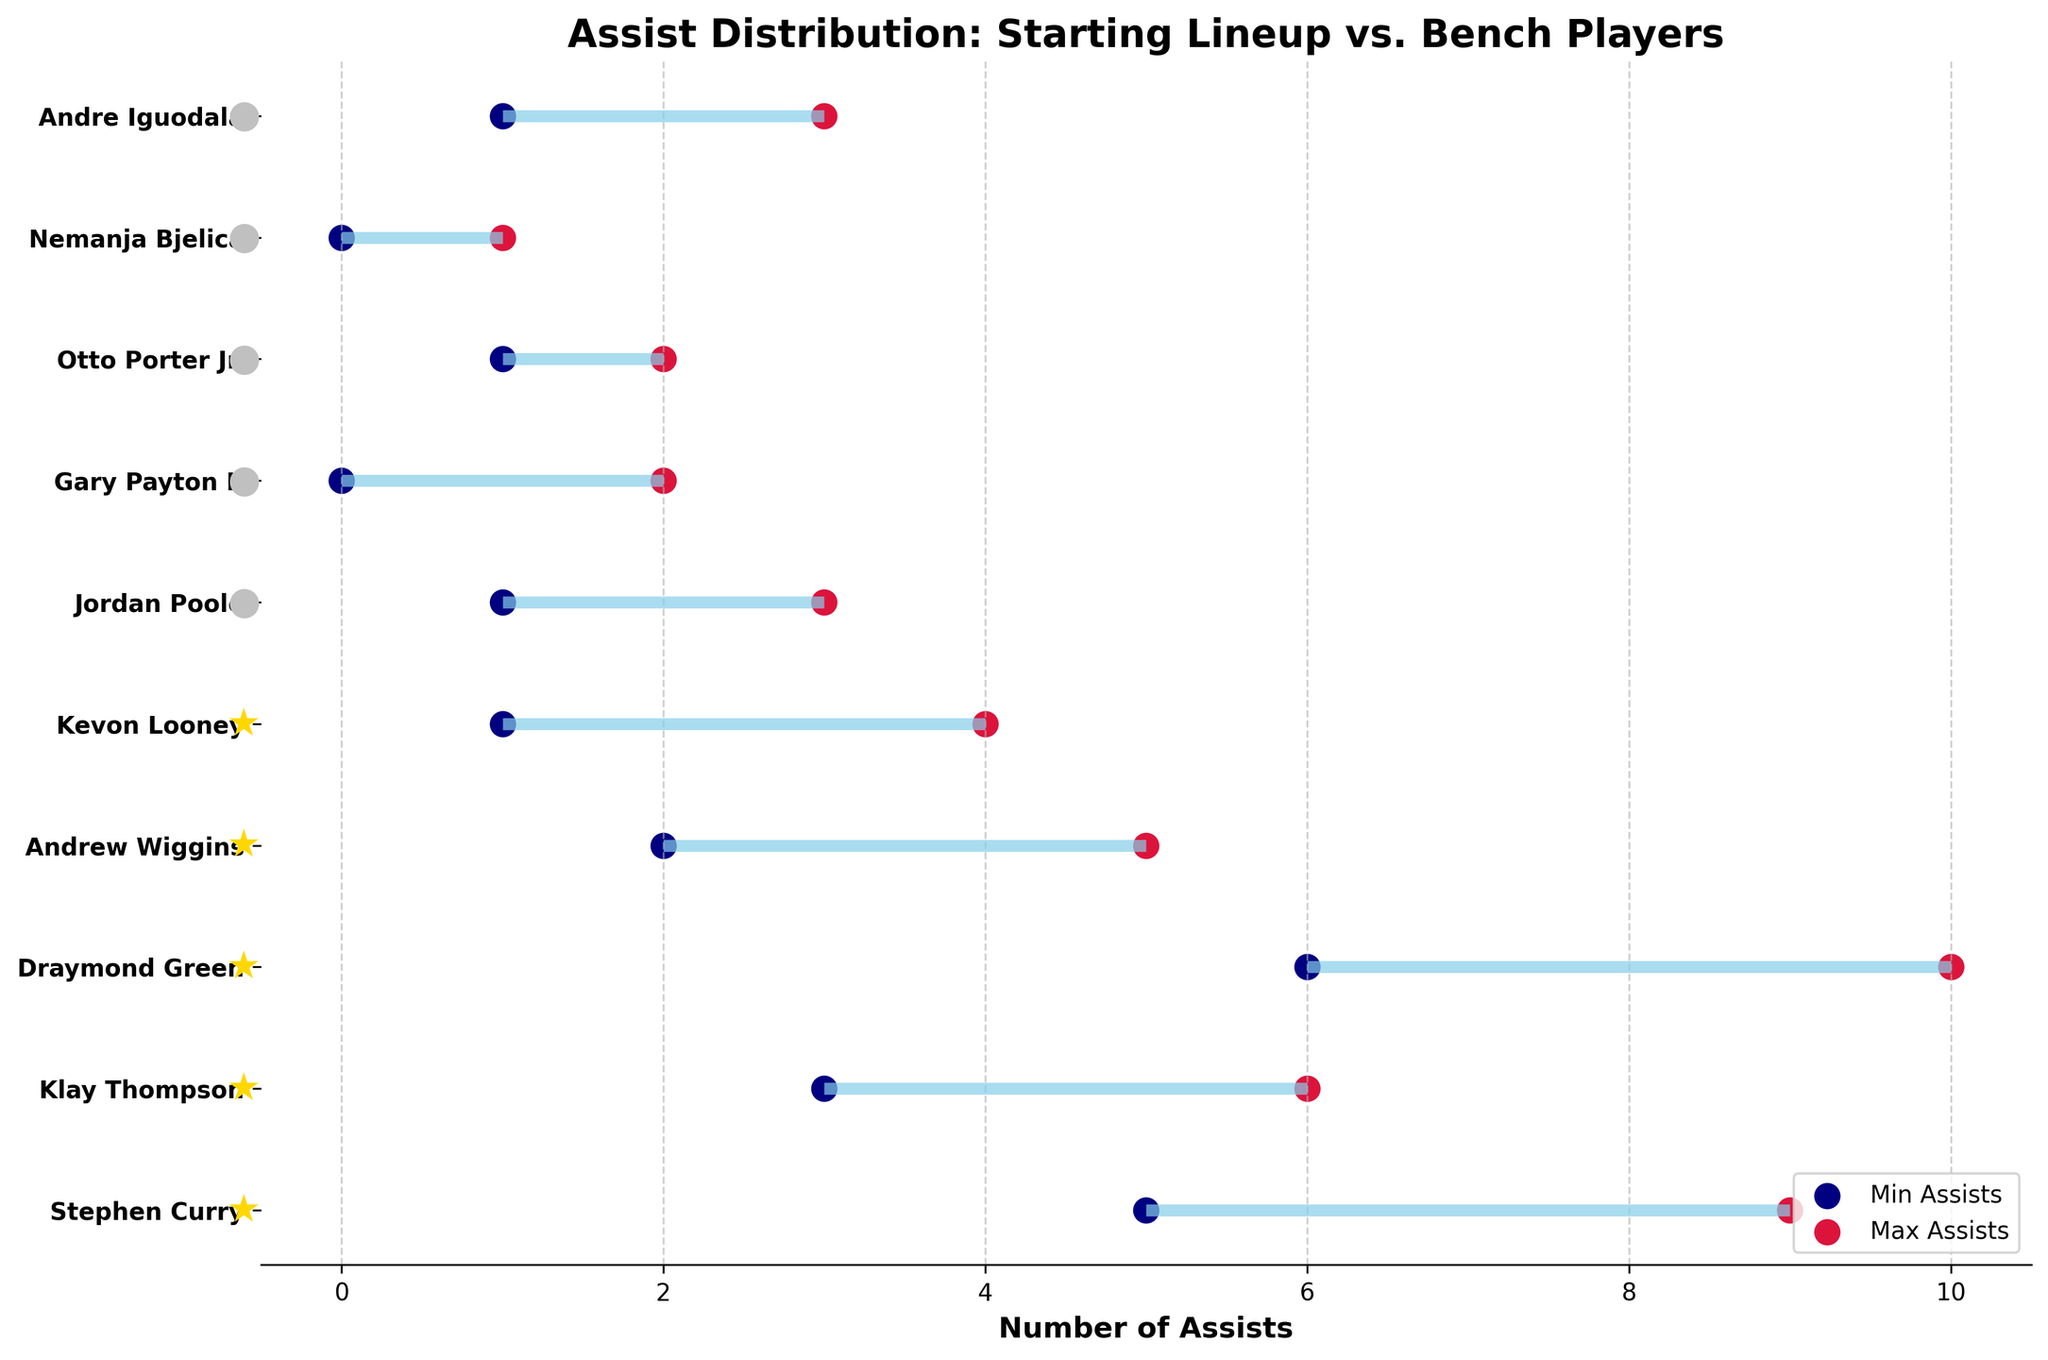What is the title of the plot? The title of the plot is the textual element that appears at the top, which helps to understand the main topic or focus.
Answer: Assist Distribution: Starting Lineup vs. Bench Players How many starting lineup players are presented in the plot? Starting lineup players are identified by a star symbol '★' next to their names. By counting these symbols, you can determine the number of starting players.
Answer: 5 Who has the maximum possible assists among the bench players? Look at the range of assists for each bench player and find the one with the highest maximum value, which is represented by the crimson dot.
Answer: Jordan Poole What is the range of assists for Draymond Green? The range of assists is indicated by the positions of the skyblue line for Draymond Green. The lower bound is shown by the navy dot, and the upper bound is shown by the crimson dot.
Answer: 6 to 10 Which starting player has the smallest maximum assists? Look at the crimson dots for all starting players and find the one with the lowest value.
Answer: Kevon Looney What is the average minimum assists for starting lineup players? Sum the minimum assists of all starting lineup players and divide by the number of starting players. (5 + 3 + 6 + 2 + 1)/5 = 17/5
Answer: 3.4 How does Stephen Curry's assist range compare to Andrew Wiggins'? Compare the minimum and maximum assist values for both players to determine the difference in ranges. Stephen Curry’s range is 5-9 and Andrew Wiggins’ is 2-5, resulting in larger range for Curry.
Answer: Stephen Curry's range is larger What is the difference in the maximum assists between the player with the highest and the player with the lowest among the starting lineup? Identify the starting players with the highest and lowest maximum assist values and subtract the lowest value from the highest. The highest is Draymond Green (10) and the lowest is Kevon Looney (4). 10 - 4 = 6.
Answer: 6 Do more starting or bench players have a minimum of at least 1 assist? Count the number of players in each category that have a minimum assist value of 1 or more. For starting players: (5: Curry, 3: Thompson, 6: Green, 2: Wiggins, 1: Looney) all have minimums of 1 or more. For bench players: (1: Poole, 0: Payton, 1: Porter Jr., 0: Bjelica, 1: Iguodala) only 3 have minimums of at least 1.
Answer: More starting players Which category, starting lineup or bench players, has a wider range of total assists? Calculate the difference between maximum and minimum assists for all players in both categories. For starting players: (10-1 = 9). For bench players: (3-0 = 3). Compare the values.
Answer: Starting lineup 